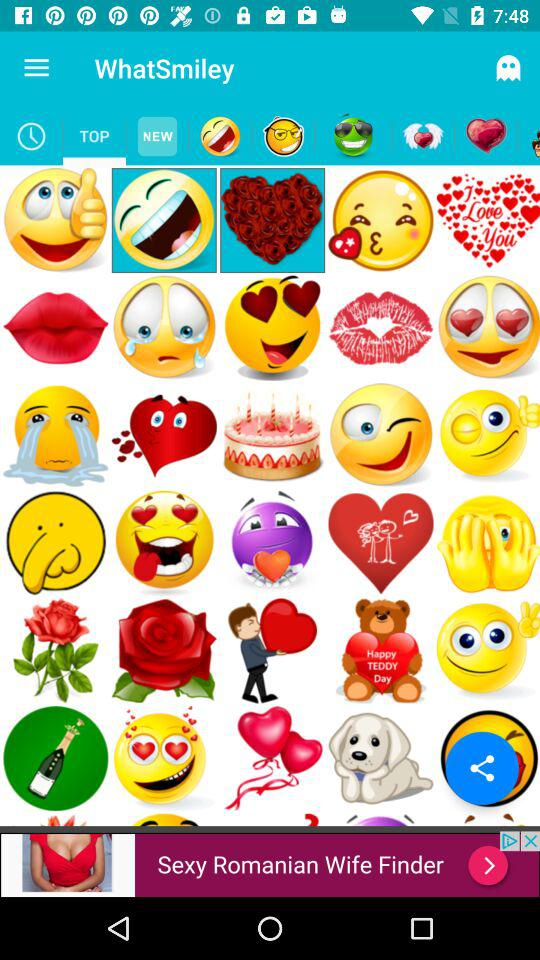What is in the history?
When the provided information is insufficient, respond with <no answer>. <no answer> 